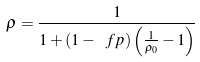<formula> <loc_0><loc_0><loc_500><loc_500>\rho = \frac { 1 } { 1 + \left ( 1 - \ f p \right ) \left ( \frac { 1 } { \rho _ { 0 } } - 1 \right ) }</formula> 